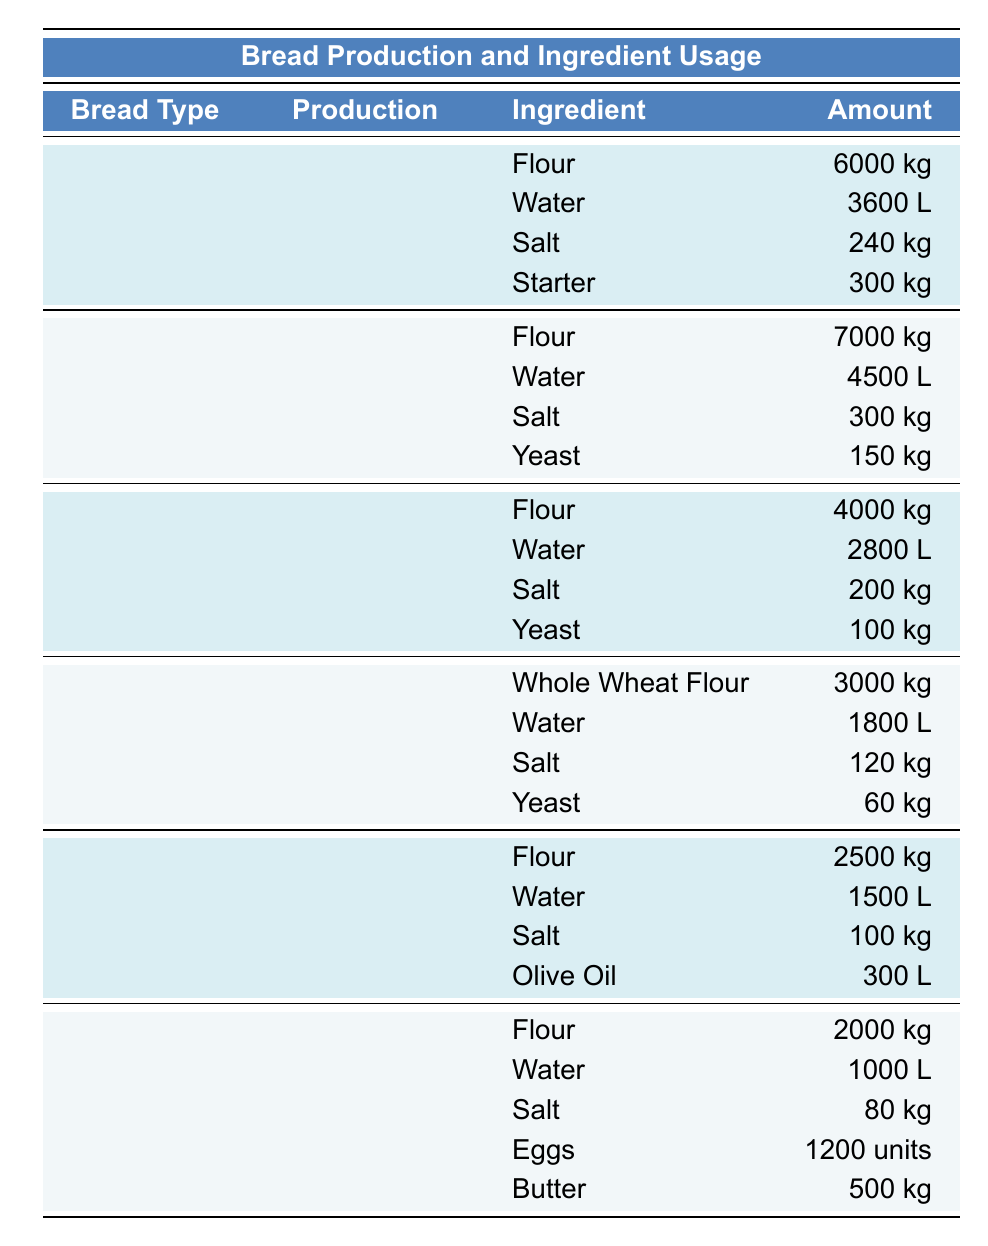What is the production volume of Baguettes? The table lists the production volumes under each bread type. For Baguette, it states "15000 loaves."
Answer: 15000 loaves How much water is used for making Sourdough? According to the table, the ingredient amount for water under Sourdough is "3600 L."
Answer: 3600 L Which type of bread uses Whole Wheat Flour? The table shows that Whole Wheat has "Whole Wheat Flour" as an ingredient, while other types do not list it.
Answer: Whole Wheat What is the total amount of Flour used for all types of bread? To find the total, sum the flour amounts: 6000 kg (Sourdough) + 7000 kg (Baguette) + 4000 kg (Ciabatta) + 3000 kg (Whole Wheat) + 2500 kg (Focaccia) + 2000 kg (Brioche) = 21500 kg.
Answer: 21500 kg Is the amount of Salt used for Brioche less than the amount used for Focaccia? The table shows that Brioche uses "80 kg," while Focaccia uses "100 kg." Since 80 kg is less than 100 kg, the statement is true.
Answer: Yes Which type of bread requires the most water? From the table, Baguette requires "4500 L" of water, which is more than Sourdough (3600 L), Ciabatta (2800 L), Whole Wheat (1800 L), Focaccia (1500 L), and Brioche (1000 L).
Answer: Baguette What is the difference in production volume between Sourdough and Whole Wheat? Sourdough has a production volume of "12000 loaves," and Whole Wheat has "6000 loaves." The difference is 12000 - 6000 = 6000 loaves.
Answer: 6000 loaves How many eggs are used in Brioche compared to the total salt used across all types? Brioche requires "1200 units" of eggs, while the total salt used is 240 kg (Sourdough) + 300 kg (Baguette) + 200 kg (Ciabatta) + 120 kg (Whole Wheat) + 100 kg (Focaccia) + 80 kg (Brioche) = 1040 kg total salt. The question looks at the two quantities but does not need to equalize them.
Answer: More eggs Is Olive Oil present in Focaccia? Referring to the table, Focaccia’s ingredients include "Olive Oil," confirming its presence.
Answer: Yes 